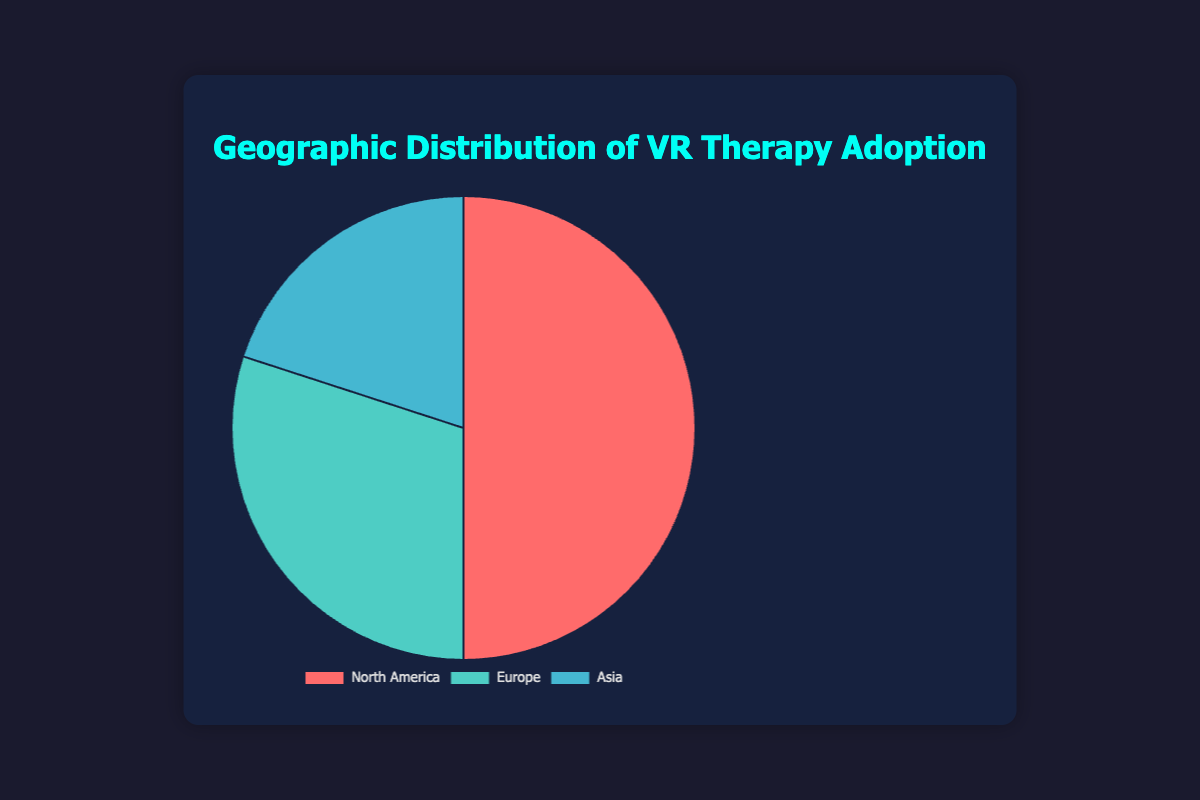Which region has the highest VR therapy adoption? By looking at the chart, the segment with the largest area represents the region with the highest adoption. North America has the largest slice.
Answer: North America What is the total percentage of VR therapy adoption in Europe and Asia combined? By adding the values for Europe (30%) and Asia (20%), you get the combined percentage.
Answer: 50% How does the adoption in North America compare to Europe? By comparing the sizes of the slices, North America's 50% is larger than Europe's 30%.
Answer: North America has higher adoption Which region has the smallest VR therapy adoption? The segment with the smallest area represents the region with the lowest adoption. Asia has the smallest slice.
Answer: Asia If we sum the adoption percentages of France and Japan, does it equal or exceed Germany's adoption percentage? Adding France (5%) and Japan (5%) gives 10%, which is equal to Germany's 10%.
Answer: Equal to Germany What is the average adoption percentage across all three regions? First sum the percentages of North America (50%), Europe (30%), and Asia (20%) to get 100%, then divide by the number of regions (3).
Answer: 33.33% If we combine the adoption percentages of Canada and China, do they count as a significant portion compared to North America? Adding Canada (10%) and China (10%) results in 20%, which is less than North America's 50%.
Answer: Less than North America What visual cue helps to quickly identify North America's adoption rate? The large, prominent slice of the pie chart represents North America.
Answer: Large slice 